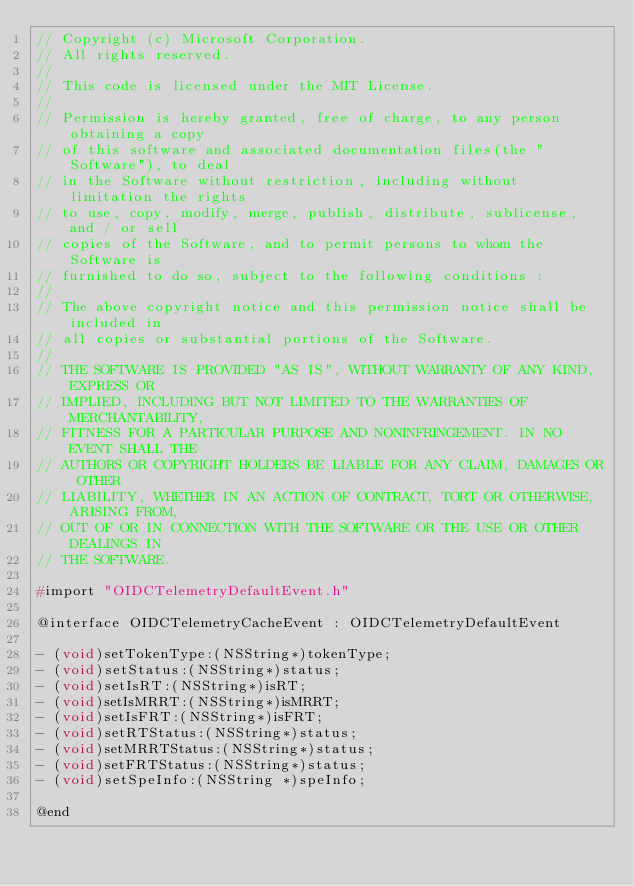<code> <loc_0><loc_0><loc_500><loc_500><_C_>// Copyright (c) Microsoft Corporation.
// All rights reserved.
//
// This code is licensed under the MIT License.
//
// Permission is hereby granted, free of charge, to any person obtaining a copy
// of this software and associated documentation files(the "Software"), to deal
// in the Software without restriction, including without limitation the rights
// to use, copy, modify, merge, publish, distribute, sublicense, and / or sell
// copies of the Software, and to permit persons to whom the Software is
// furnished to do so, subject to the following conditions :
//
// The above copyright notice and this permission notice shall be included in
// all copies or substantial portions of the Software.
//
// THE SOFTWARE IS PROVIDED "AS IS", WITHOUT WARRANTY OF ANY KIND, EXPRESS OR
// IMPLIED, INCLUDING BUT NOT LIMITED TO THE WARRANTIES OF MERCHANTABILITY,
// FITNESS FOR A PARTICULAR PURPOSE AND NONINFRINGEMENT. IN NO EVENT SHALL THE
// AUTHORS OR COPYRIGHT HOLDERS BE LIABLE FOR ANY CLAIM, DAMAGES OR OTHER
// LIABILITY, WHETHER IN AN ACTION OF CONTRACT, TORT OR OTHERWISE, ARISING FROM,
// OUT OF OR IN CONNECTION WITH THE SOFTWARE OR THE USE OR OTHER DEALINGS IN
// THE SOFTWARE.

#import "OIDCTelemetryDefaultEvent.h"

@interface OIDCTelemetryCacheEvent : OIDCTelemetryDefaultEvent

- (void)setTokenType:(NSString*)tokenType;
- (void)setStatus:(NSString*)status;
- (void)setIsRT:(NSString*)isRT;
- (void)setIsMRRT:(NSString*)isMRRT;
- (void)setIsFRT:(NSString*)isFRT;
- (void)setRTStatus:(NSString*)status;
- (void)setMRRTStatus:(NSString*)status;
- (void)setFRTStatus:(NSString*)status;
- (void)setSpeInfo:(NSString *)speInfo;

@end
</code> 